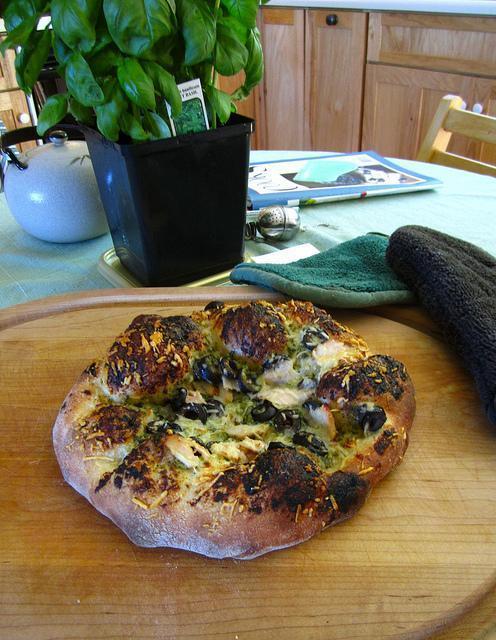Does the description: "The potted plant is far away from the pizza." accurately reflect the image?
Answer yes or no. No. 